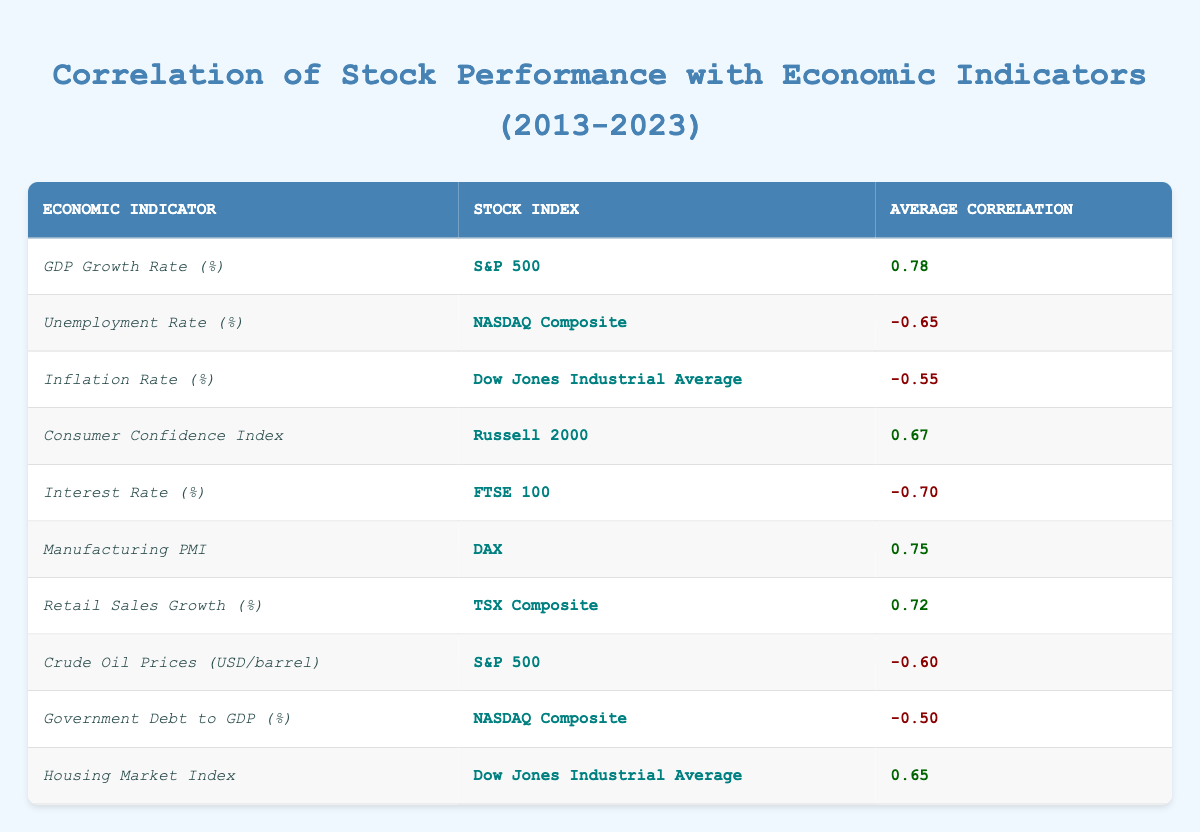What is the average correlation of GDP Growth Rate with S&P 500? The average correlation for the GDP Growth Rate with S&P 500 is listed in the table as 0.78.
Answer: 0.78 What is the correlation between the Unemployment Rate and the NASDAQ Composite? The table shows that the correlation between the Unemployment Rate and the NASDAQ Composite is -0.65.
Answer: -0.65 Which stock index has the highest positive correlation with economic indicators? By reviewing the average correlation values, the S&P 500 has the highest positive correlation of 0.78 with the GDP Growth Rate.
Answer: S&P 500 Is there any economic indicator that correlates positively with the Dow Jones Industrial Average? Yes, the Housing Market Index has a positive correlation of 0.65 with the Dow Jones Industrial Average, as indicated in the table.
Answer: Yes What is the correlation of Interest Rate with FTSE 100? The correlation of Interest Rate with FTSE 100 is -0.70, as specified in the table.
Answer: -0.70 Which stock index shows a negative correlation with both Unemployment Rate and Government Debt to GDP? The NASDAQ Composite shows negative correlations with both the Unemployment Rate (-0.65) and Government Debt to GDP (-0.50).
Answer: NASDAQ Composite What is the average correlation for the stock index DAX? The average correlation for the DAX is 0.75 with the Manufacturing PMI.
Answer: 0.75 Identify the stock index with the strongest negative correlation and the corresponding economic indicator. The stock index with the strongest negative correlation is FTSE 100, correlated with Interest Rate at -0.70.
Answer: FTSE 100 and Interest Rate How does the correlation of Crude Oil Prices affect the S&P 500? The table indicates that the correlation of Crude Oil Prices with the S&P 500 is -0.60, suggesting a negative relationship. Thus, when Crude Oil Prices rise, S&P 500 tends to decrease.
Answer: Negative correlation of -0.60 Which economic indicator shows the least negative correlation in the table? The least negative correlation is Government Debt to GDP, with a correlation of -0.50, which is higher than the others listed in negative terms.
Answer: Government Debt to GDP 